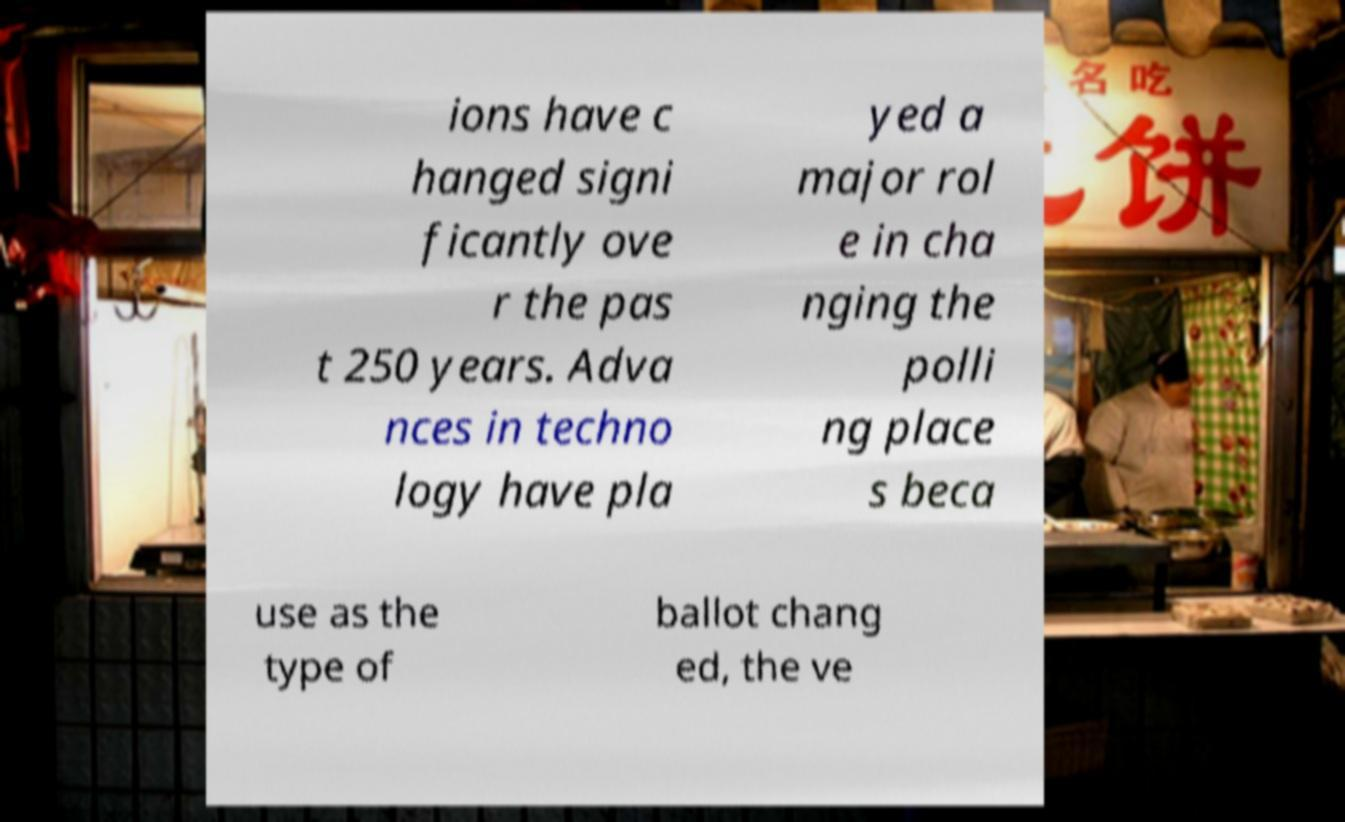Could you extract and type out the text from this image? ions have c hanged signi ficantly ove r the pas t 250 years. Adva nces in techno logy have pla yed a major rol e in cha nging the polli ng place s beca use as the type of ballot chang ed, the ve 